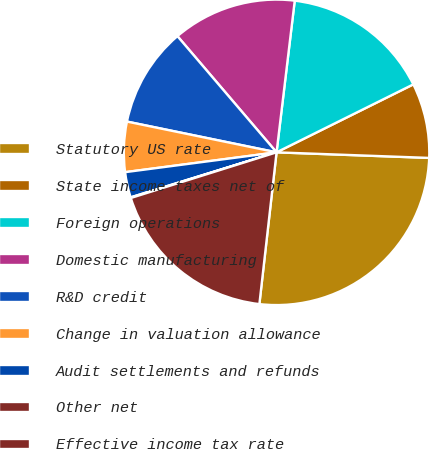<chart> <loc_0><loc_0><loc_500><loc_500><pie_chart><fcel>Statutory US rate<fcel>State income taxes net of<fcel>Foreign operations<fcel>Domestic manufacturing<fcel>R&D credit<fcel>Change in valuation allowance<fcel>Audit settlements and refunds<fcel>Other net<fcel>Effective income tax rate<nl><fcel>26.21%<fcel>7.92%<fcel>15.76%<fcel>13.14%<fcel>10.53%<fcel>5.3%<fcel>2.69%<fcel>0.07%<fcel>18.37%<nl></chart> 